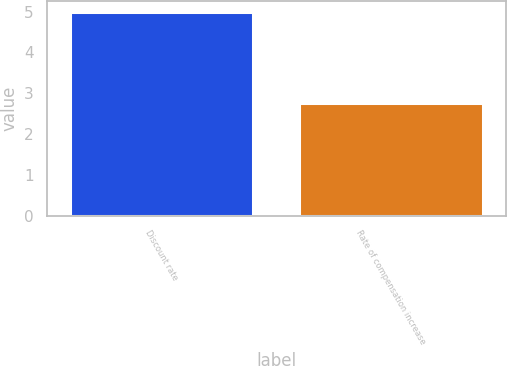<chart> <loc_0><loc_0><loc_500><loc_500><bar_chart><fcel>Discount rate<fcel>Rate of compensation increase<nl><fcel>5<fcel>2.75<nl></chart> 